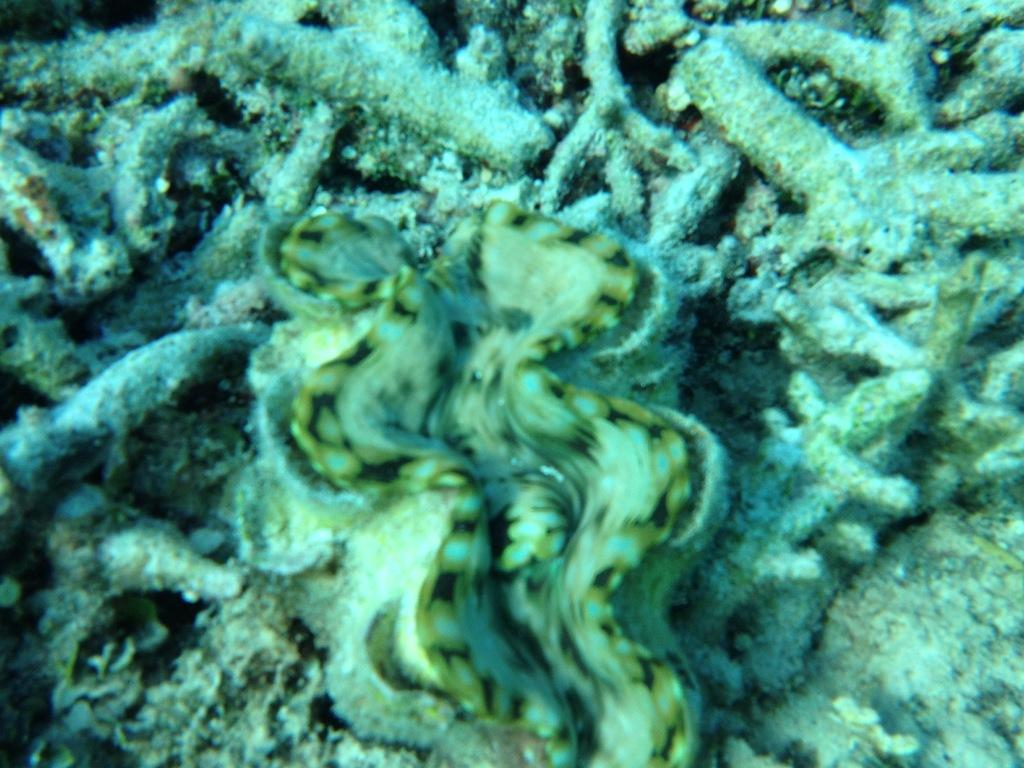What type of clam is present in the image? There is a Tridacna clam in the image. What other creatures can be seen in the image? There are aquatic animals in the image. What type of wheel can be seen in the image? There is no wheel present in the image; it features a Tridacna clam and aquatic animals. Can you tell me how many combs are being used by the aquatic animals in the image? There are no combs present in the image, as it features a Tridacna clam and aquatic animals in an aquatic environment. 